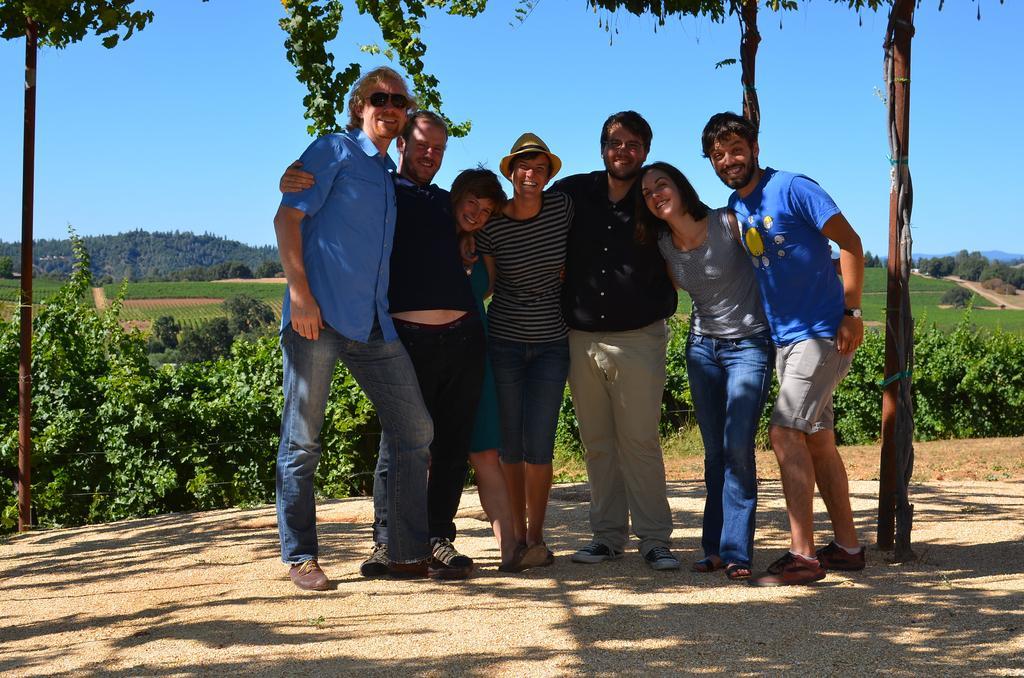In one or two sentences, can you explain what this image depicts? in this image in the center there are group of persons standing and smiling. In the background there are plants and there are trees. On the top there are leaves and there are poles in the center. 